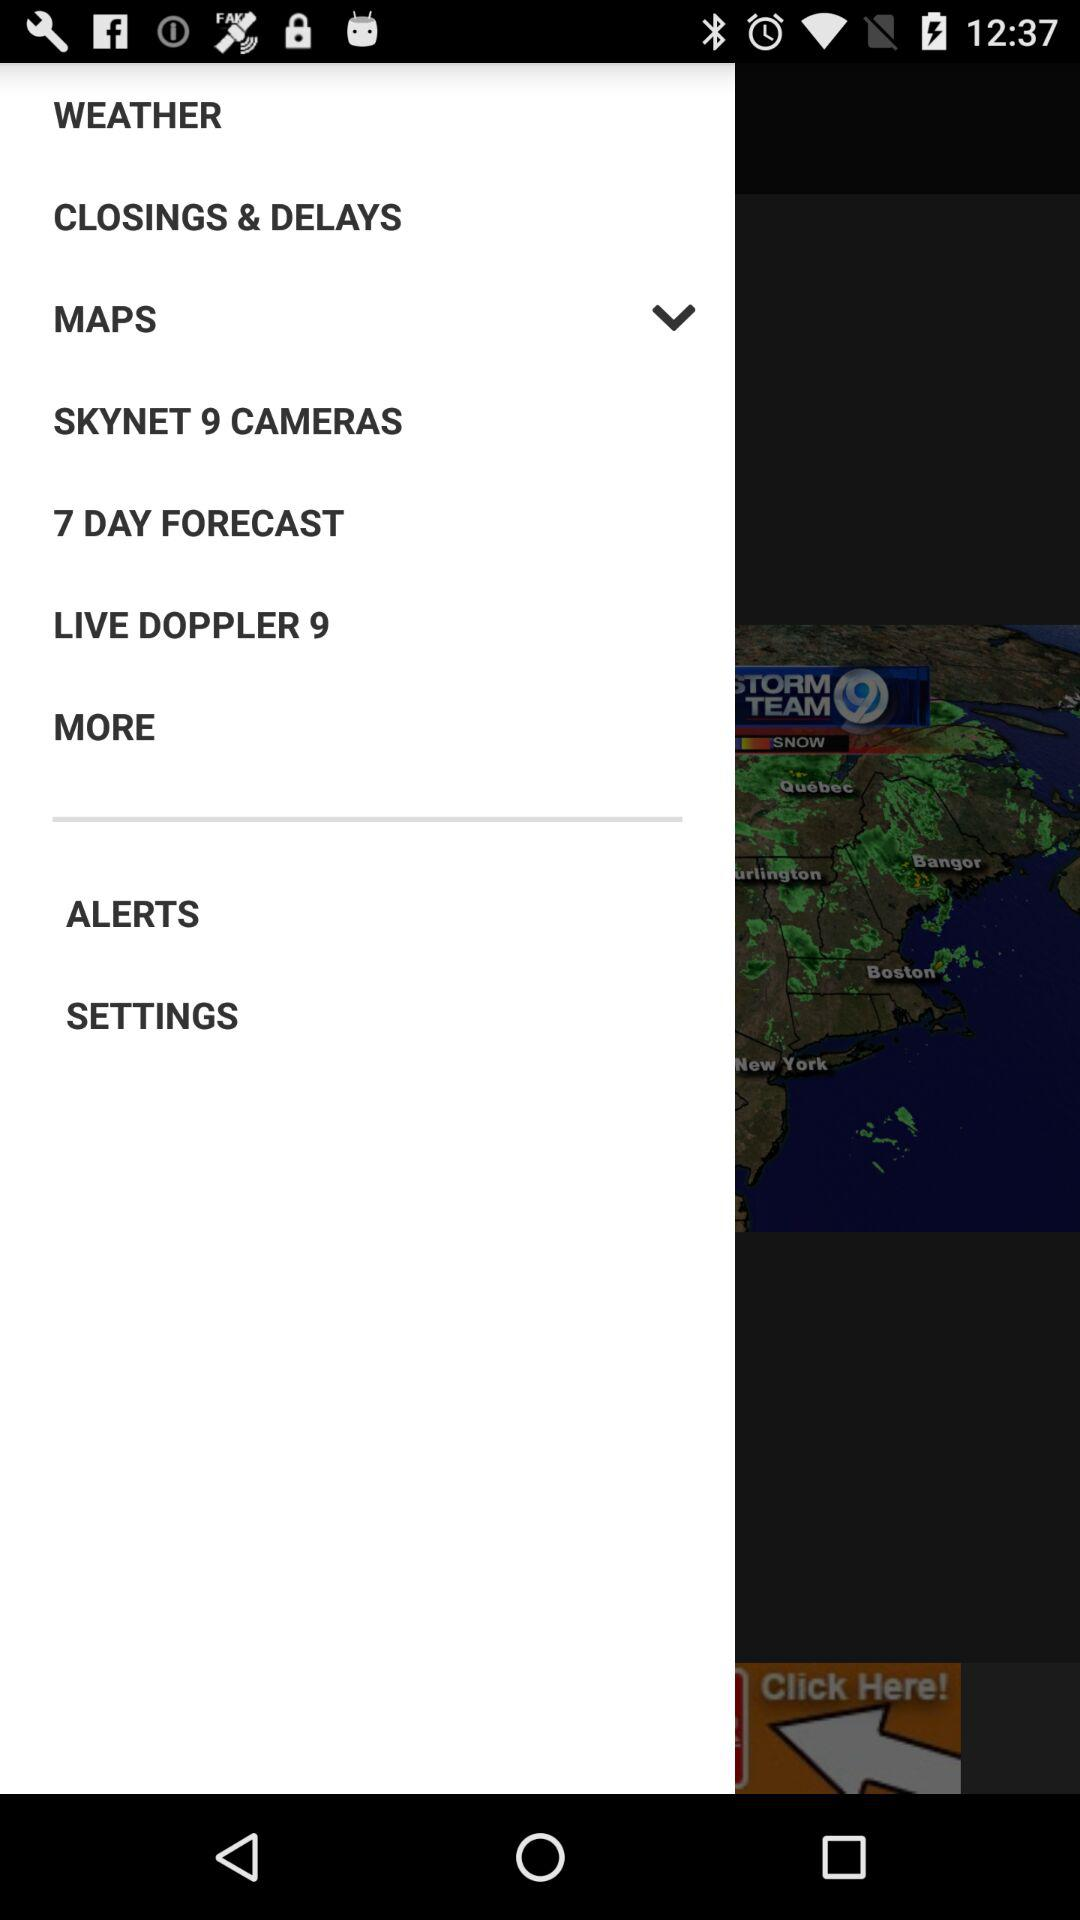How many days are selected for the forecast?
When the provided information is insufficient, respond with <no answer>. <no answer> 